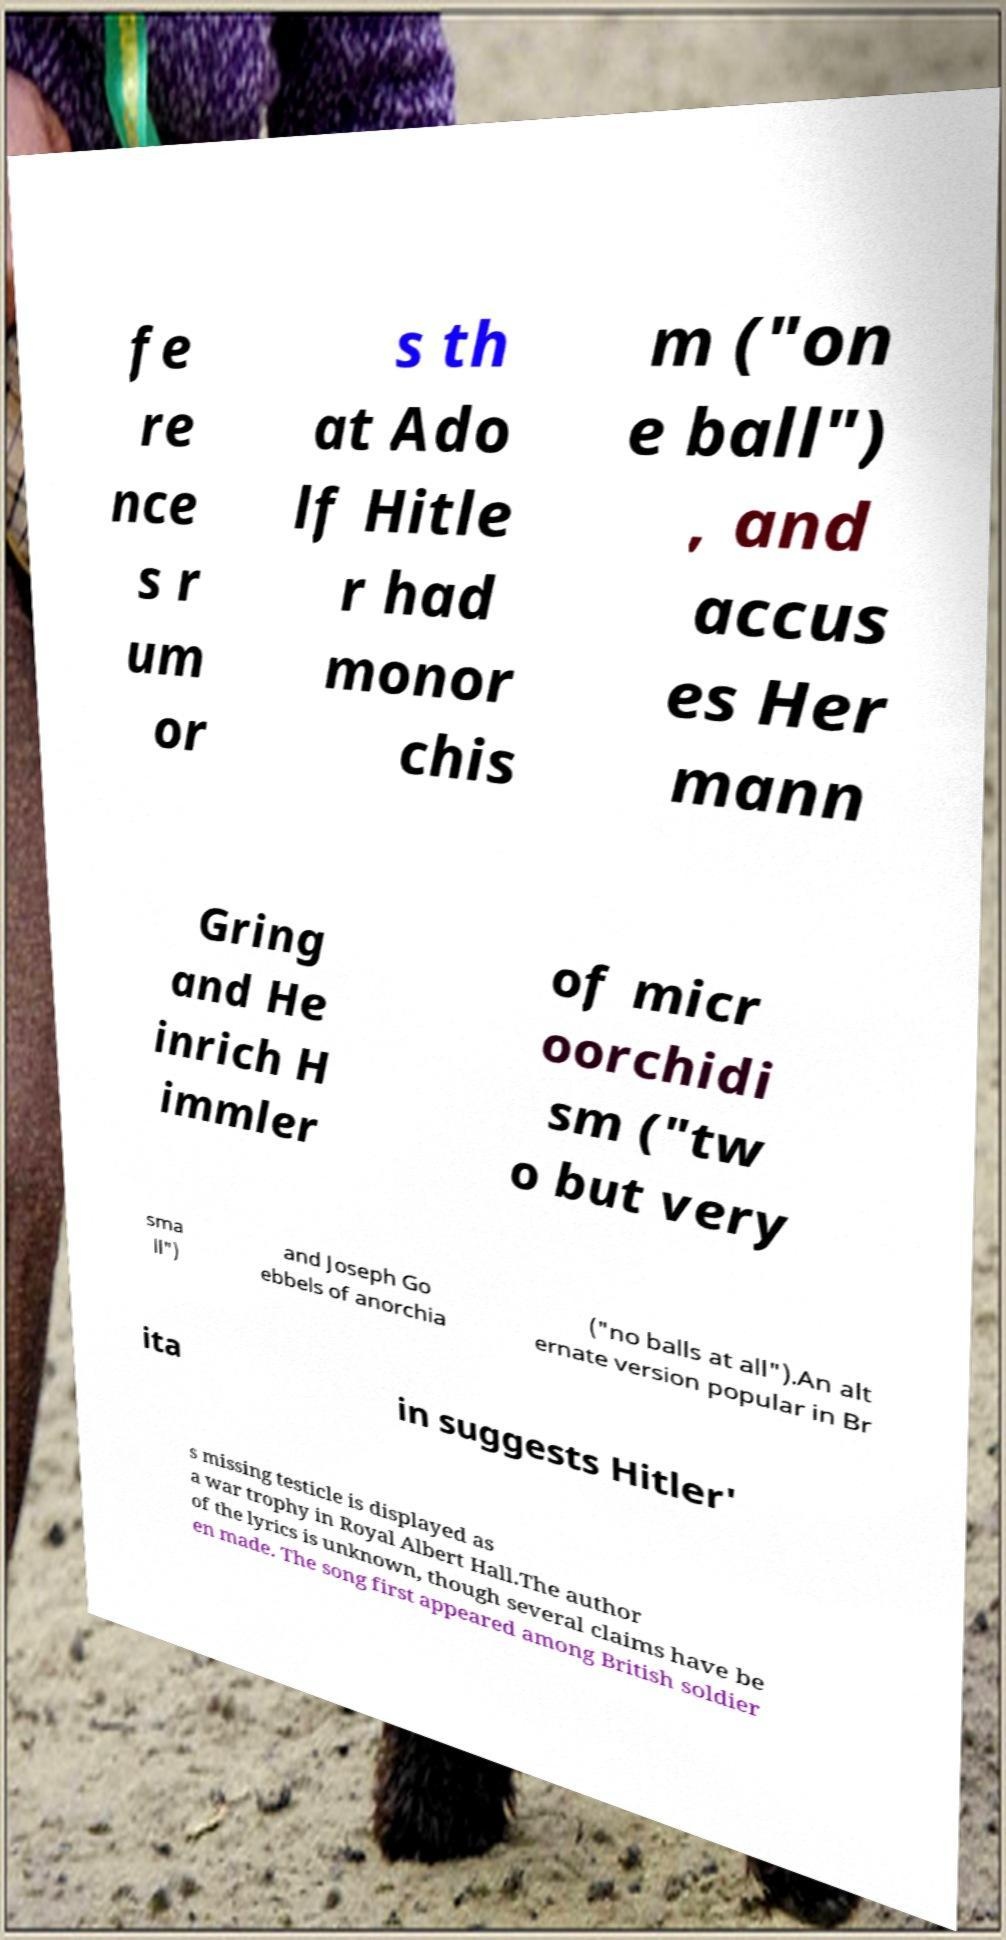Can you read and provide the text displayed in the image?This photo seems to have some interesting text. Can you extract and type it out for me? fe re nce s r um or s th at Ado lf Hitle r had monor chis m ("on e ball") , and accus es Her mann Gring and He inrich H immler of micr oorchidi sm ("tw o but very sma ll") and Joseph Go ebbels of anorchia ("no balls at all").An alt ernate version popular in Br ita in suggests Hitler' s missing testicle is displayed as a war trophy in Royal Albert Hall.The author of the lyrics is unknown, though several claims have be en made. The song first appeared among British soldier 